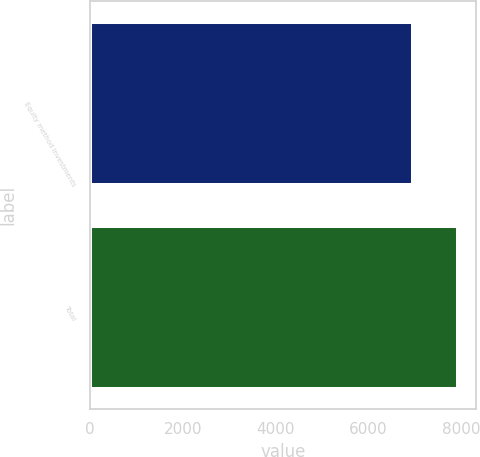<chart> <loc_0><loc_0><loc_500><loc_500><bar_chart><fcel>Equity method investments<fcel>Total<nl><fcel>6954<fcel>7918<nl></chart> 